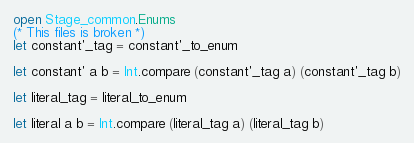Convert code to text. <code><loc_0><loc_0><loc_500><loc_500><_OCaml_>open Stage_common.Enums
(* This files is broken *)
let constant'_tag = constant'_to_enum

let constant' a b = Int.compare (constant'_tag a) (constant'_tag b)

let literal_tag = literal_to_enum

let literal a b = Int.compare (literal_tag a) (literal_tag b)
</code> 